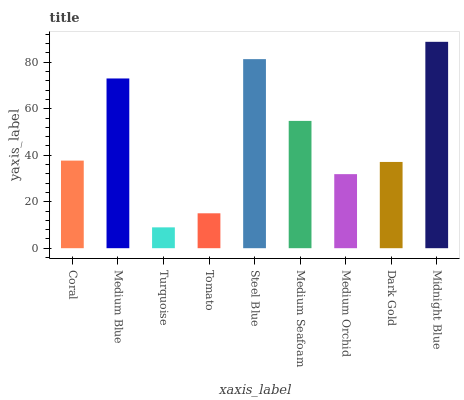Is Turquoise the minimum?
Answer yes or no. Yes. Is Midnight Blue the maximum?
Answer yes or no. Yes. Is Medium Blue the minimum?
Answer yes or no. No. Is Medium Blue the maximum?
Answer yes or no. No. Is Medium Blue greater than Coral?
Answer yes or no. Yes. Is Coral less than Medium Blue?
Answer yes or no. Yes. Is Coral greater than Medium Blue?
Answer yes or no. No. Is Medium Blue less than Coral?
Answer yes or no. No. Is Coral the high median?
Answer yes or no. Yes. Is Coral the low median?
Answer yes or no. Yes. Is Dark Gold the high median?
Answer yes or no. No. Is Medium Seafoam the low median?
Answer yes or no. No. 